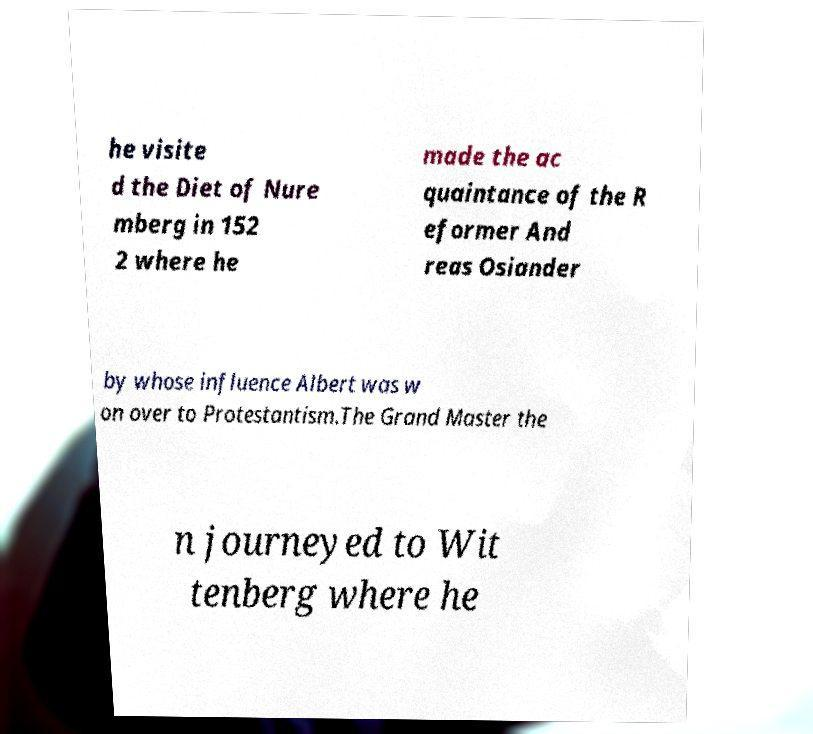What messages or text are displayed in this image? I need them in a readable, typed format. he visite d the Diet of Nure mberg in 152 2 where he made the ac quaintance of the R eformer And reas Osiander by whose influence Albert was w on over to Protestantism.The Grand Master the n journeyed to Wit tenberg where he 